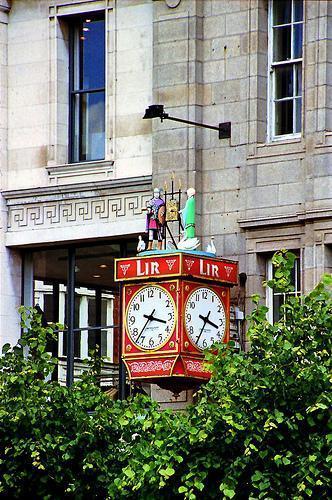How many clock faces are in the photo?
Give a very brief answer. 2. 